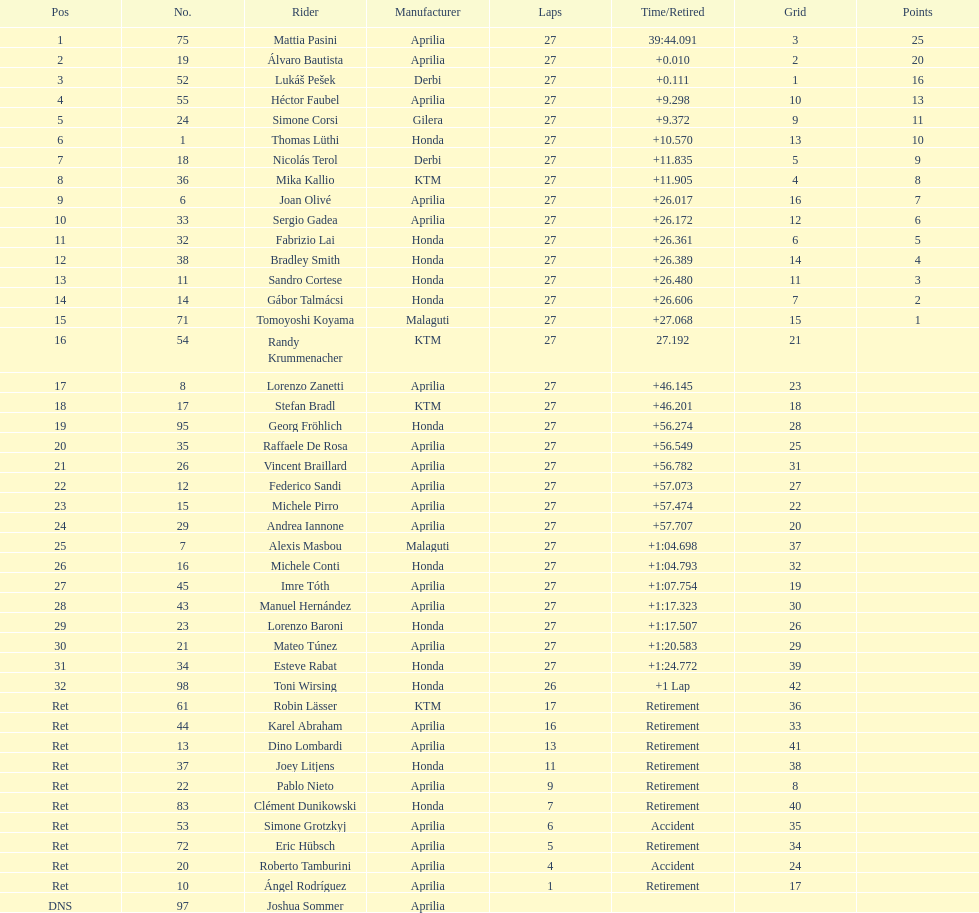Of everyone holding points, who has the minimum? Tomoyoshi Koyama. 